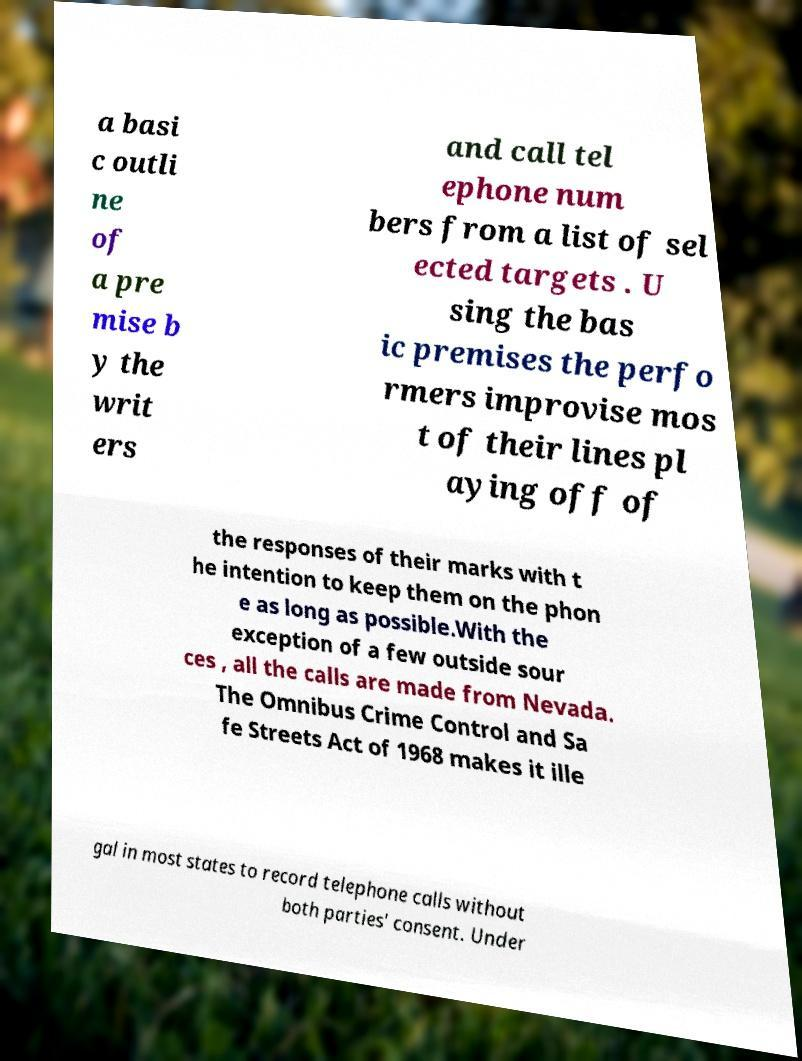There's text embedded in this image that I need extracted. Can you transcribe it verbatim? a basi c outli ne of a pre mise b y the writ ers and call tel ephone num bers from a list of sel ected targets . U sing the bas ic premises the perfo rmers improvise mos t of their lines pl aying off of the responses of their marks with t he intention to keep them on the phon e as long as possible.With the exception of a few outside sour ces , all the calls are made from Nevada. The Omnibus Crime Control and Sa fe Streets Act of 1968 makes it ille gal in most states to record telephone calls without both parties' consent. Under 